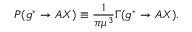Convert formula to latex. <formula><loc_0><loc_0><loc_500><loc_500>P ( g ^ { * } \rightarrow A X ) \equiv \frac { 1 } { \pi \mu ^ { 3 } } \Gamma ( g ^ { * } \rightarrow A X ) .</formula> 